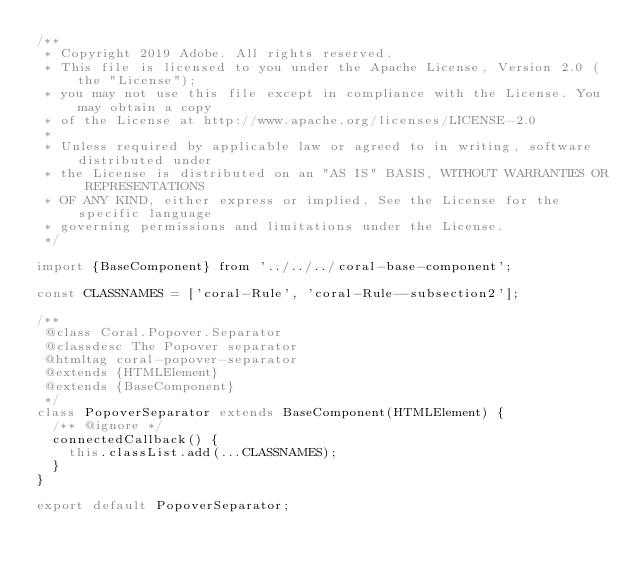<code> <loc_0><loc_0><loc_500><loc_500><_JavaScript_>/**
 * Copyright 2019 Adobe. All rights reserved.
 * This file is licensed to you under the Apache License, Version 2.0 (the "License");
 * you may not use this file except in compliance with the License. You may obtain a copy
 * of the License at http://www.apache.org/licenses/LICENSE-2.0
 *
 * Unless required by applicable law or agreed to in writing, software distributed under
 * the License is distributed on an "AS IS" BASIS, WITHOUT WARRANTIES OR REPRESENTATIONS
 * OF ANY KIND, either express or implied. See the License for the specific language
 * governing permissions and limitations under the License.
 */

import {BaseComponent} from '../../../coral-base-component';

const CLASSNAMES = ['coral-Rule', 'coral-Rule--subsection2'];

/**
 @class Coral.Popover.Separator
 @classdesc The Popover separator
 @htmltag coral-popover-separator
 @extends {HTMLElement}
 @extends {BaseComponent}
 */
class PopoverSeparator extends BaseComponent(HTMLElement) {
  /** @ignore */
  connectedCallback() {
    this.classList.add(...CLASSNAMES);
  }
}

export default PopoverSeparator;
</code> 